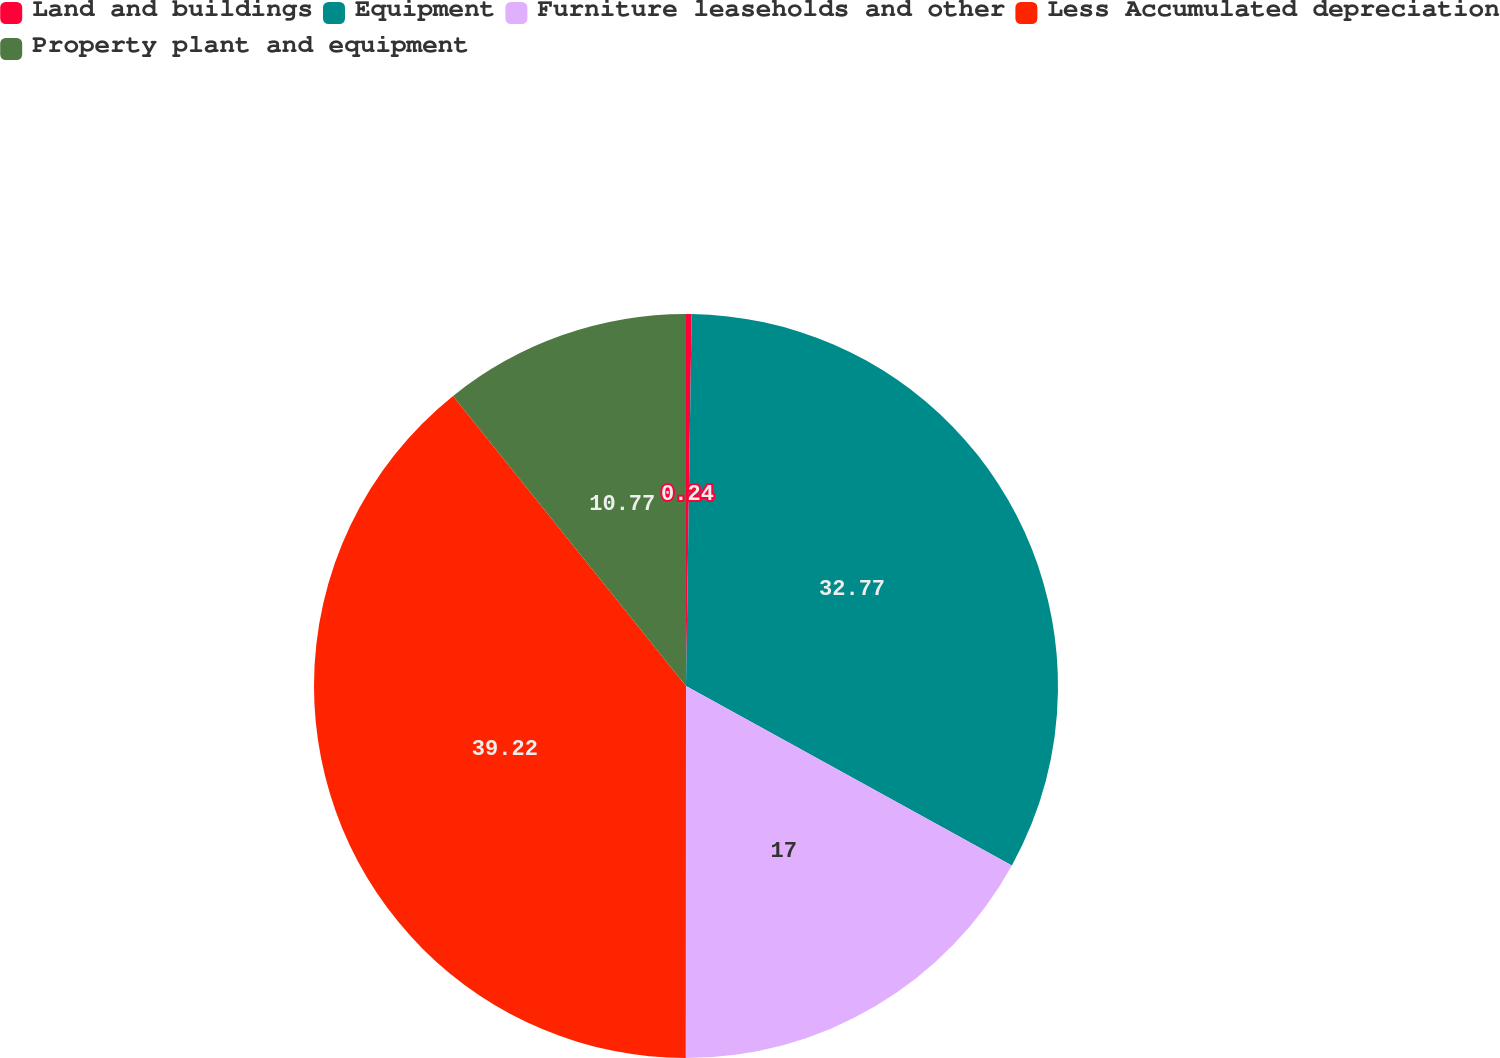Convert chart to OTSL. <chart><loc_0><loc_0><loc_500><loc_500><pie_chart><fcel>Land and buildings<fcel>Equipment<fcel>Furniture leaseholds and other<fcel>Less Accumulated depreciation<fcel>Property plant and equipment<nl><fcel>0.24%<fcel>32.77%<fcel>17.0%<fcel>39.22%<fcel>10.77%<nl></chart> 